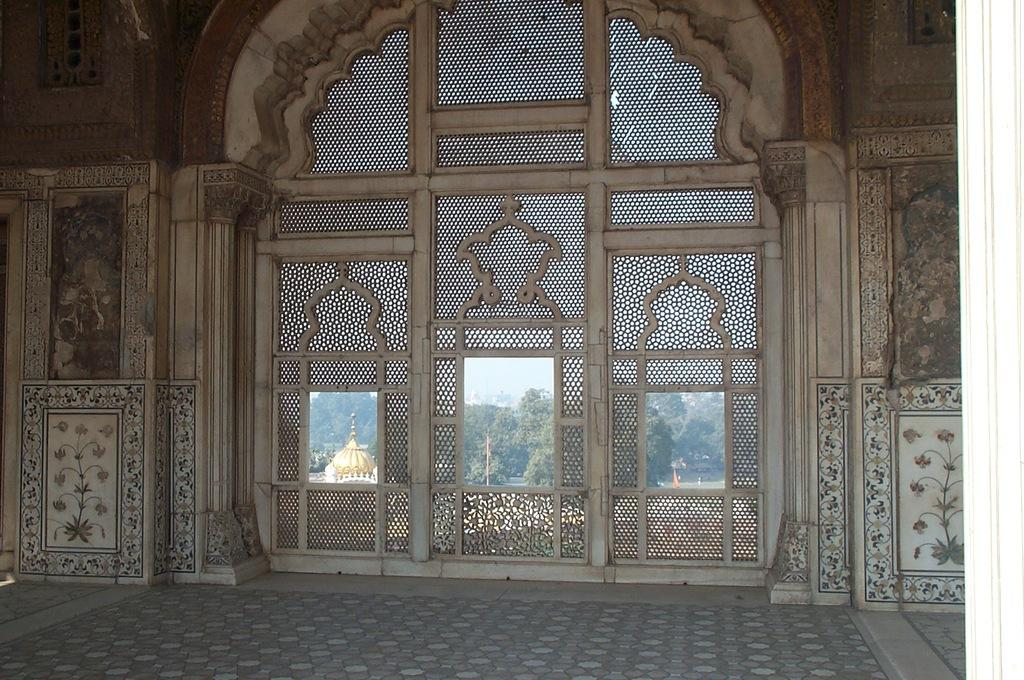What type of structure can be seen in the image? There is a wall and a door in the image. What is visible behind the door? Trees are visible behind the door. What other objects can be seen in the background of the image? There is a pole and a dome-like structure in the background of the image. What is visible in the sky in the image? The sky is visible in the background of the image. How many chickens are playing with balls in the image? There are no chickens or balls present in the image. Is there a fireman visible in the image? There is no fireman present in the image. 